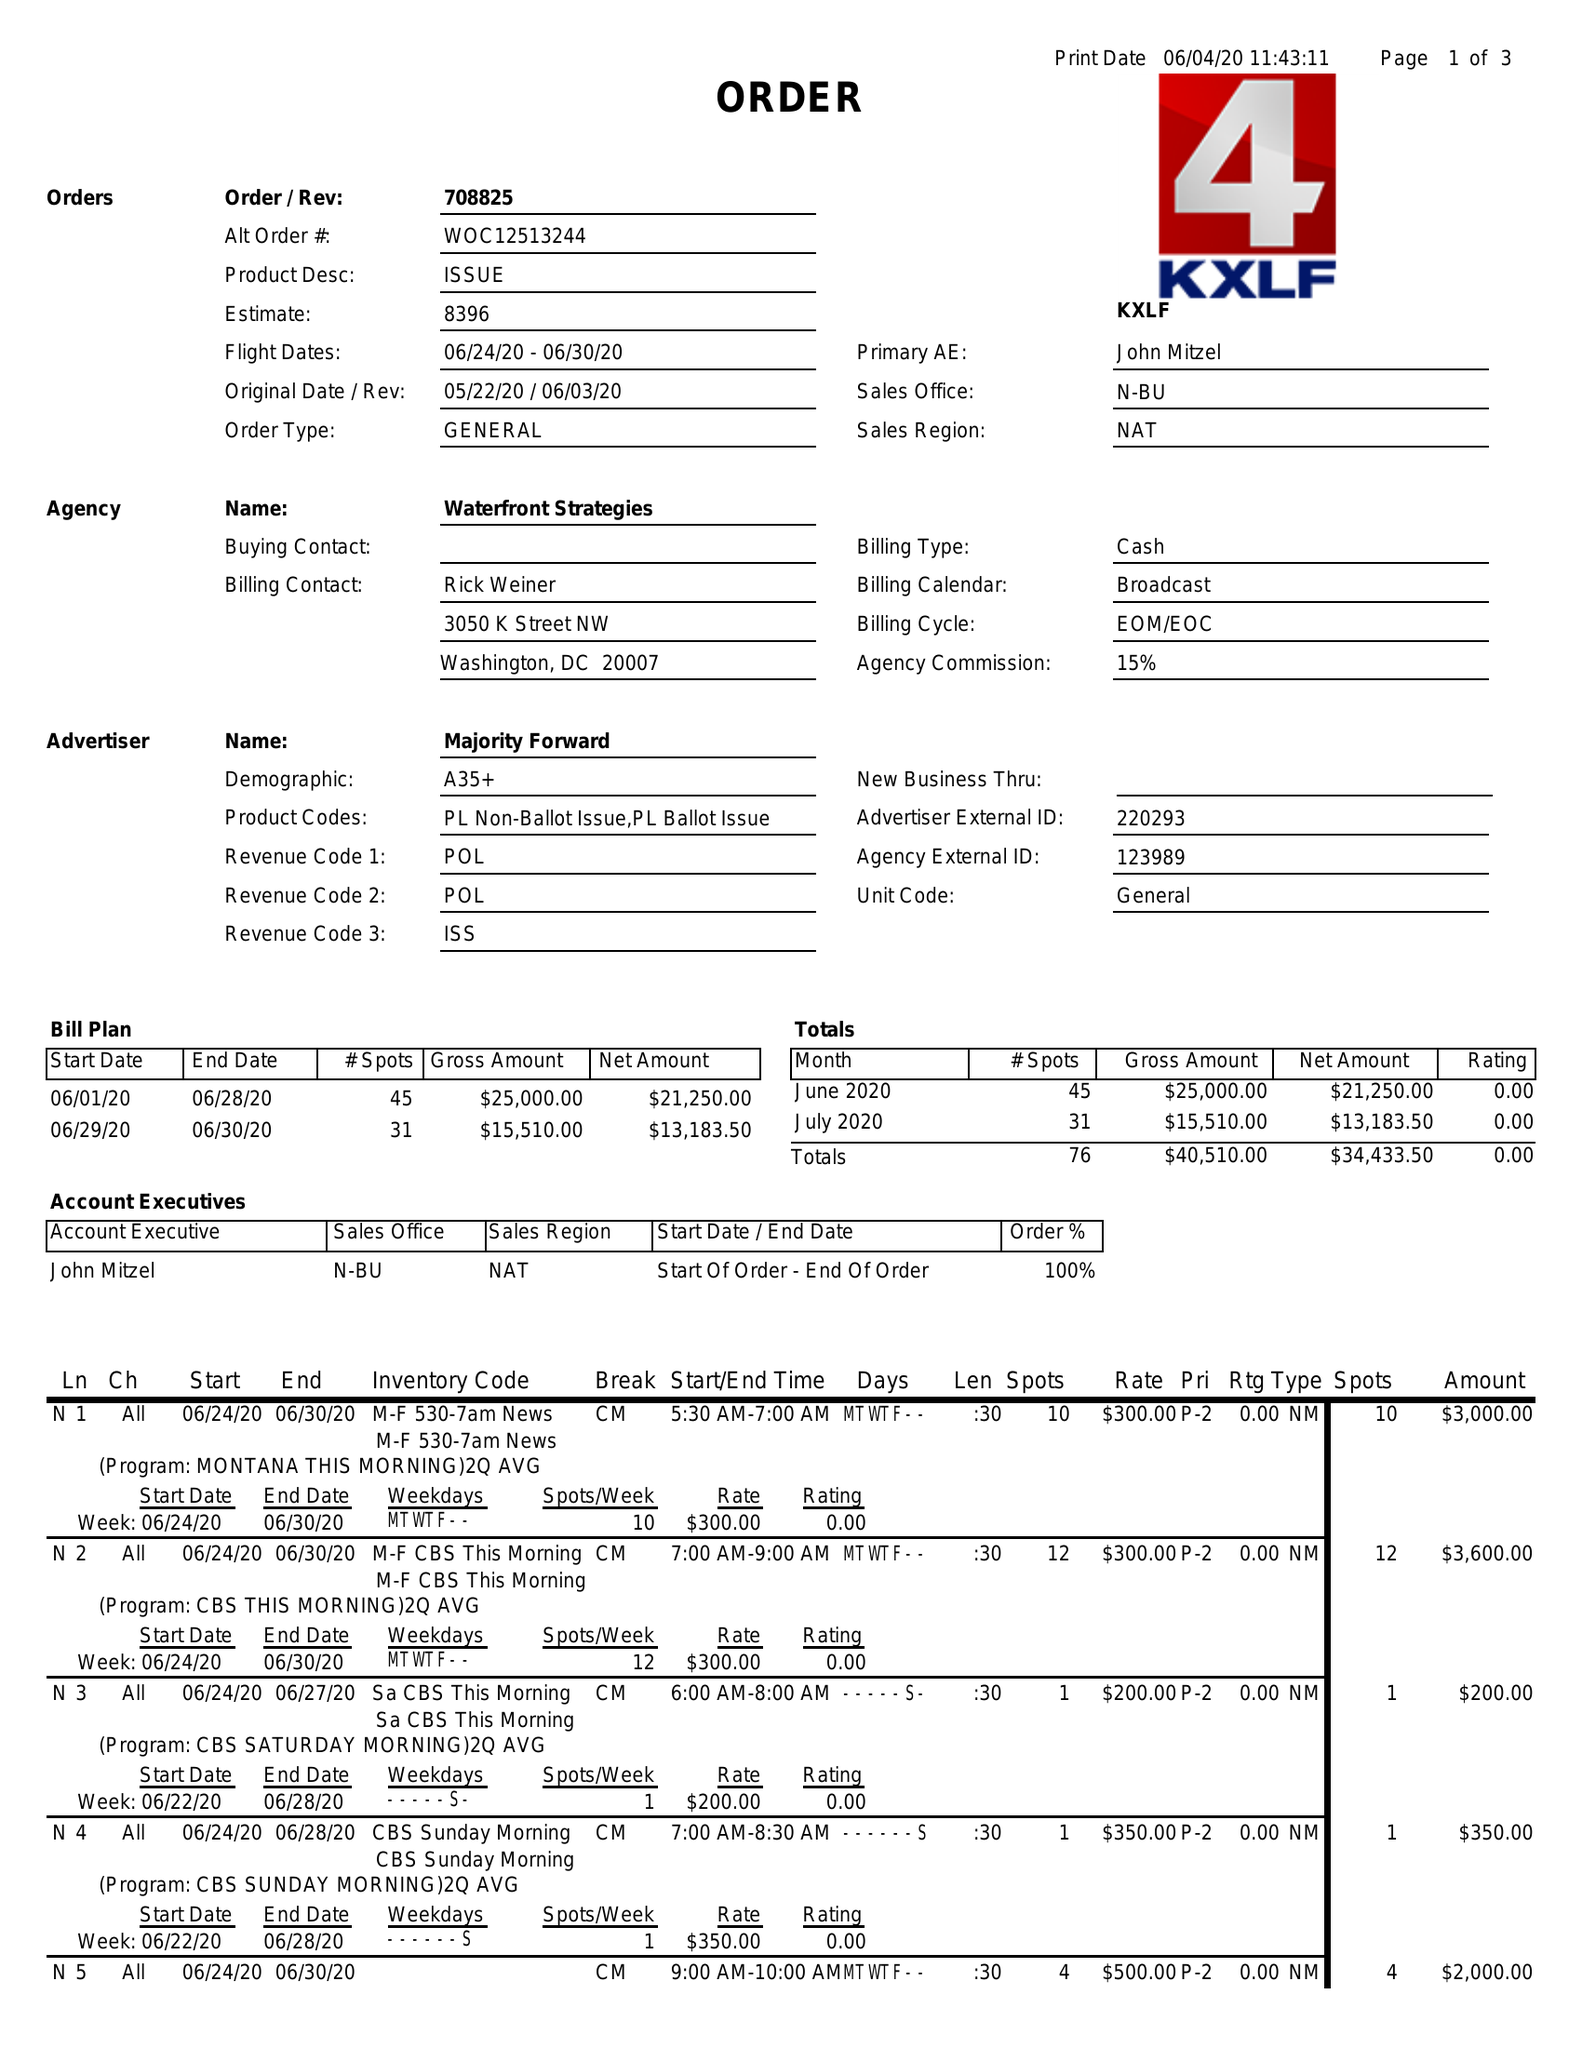What is the value for the flight_from?
Answer the question using a single word or phrase. 06/24/20 